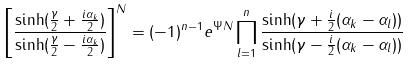Convert formula to latex. <formula><loc_0><loc_0><loc_500><loc_500>\left [ \frac { \sinh ( \frac { \gamma } { 2 } + \frac { i \alpha _ { k } } { 2 } ) } { \sinh ( \frac { \gamma } { 2 } - \frac { i \alpha _ { k } } { 2 } ) } \right ] ^ { N } = ( - 1 ) ^ { n - 1 } e ^ { \Psi N } \prod _ { l = 1 } ^ { n } \frac { \sinh ( \gamma + \frac { i } { 2 } ( \alpha _ { k } - \alpha _ { l } ) ) } { \sinh ( \gamma - \frac { i } { 2 } ( \alpha _ { k } - \alpha _ { l } ) ) }</formula> 